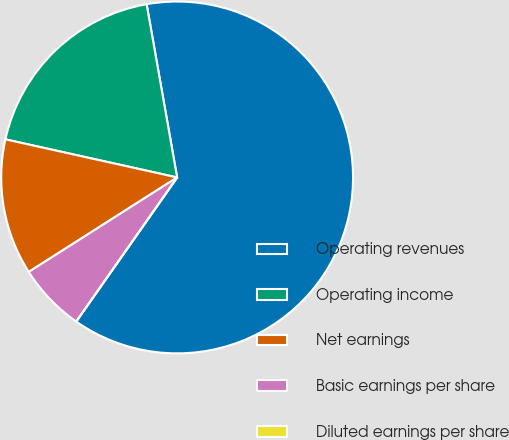<chart> <loc_0><loc_0><loc_500><loc_500><pie_chart><fcel>Operating revenues<fcel>Operating income<fcel>Net earnings<fcel>Basic earnings per share<fcel>Diluted earnings per share<nl><fcel>62.5%<fcel>18.75%<fcel>12.5%<fcel>6.25%<fcel>0.0%<nl></chart> 